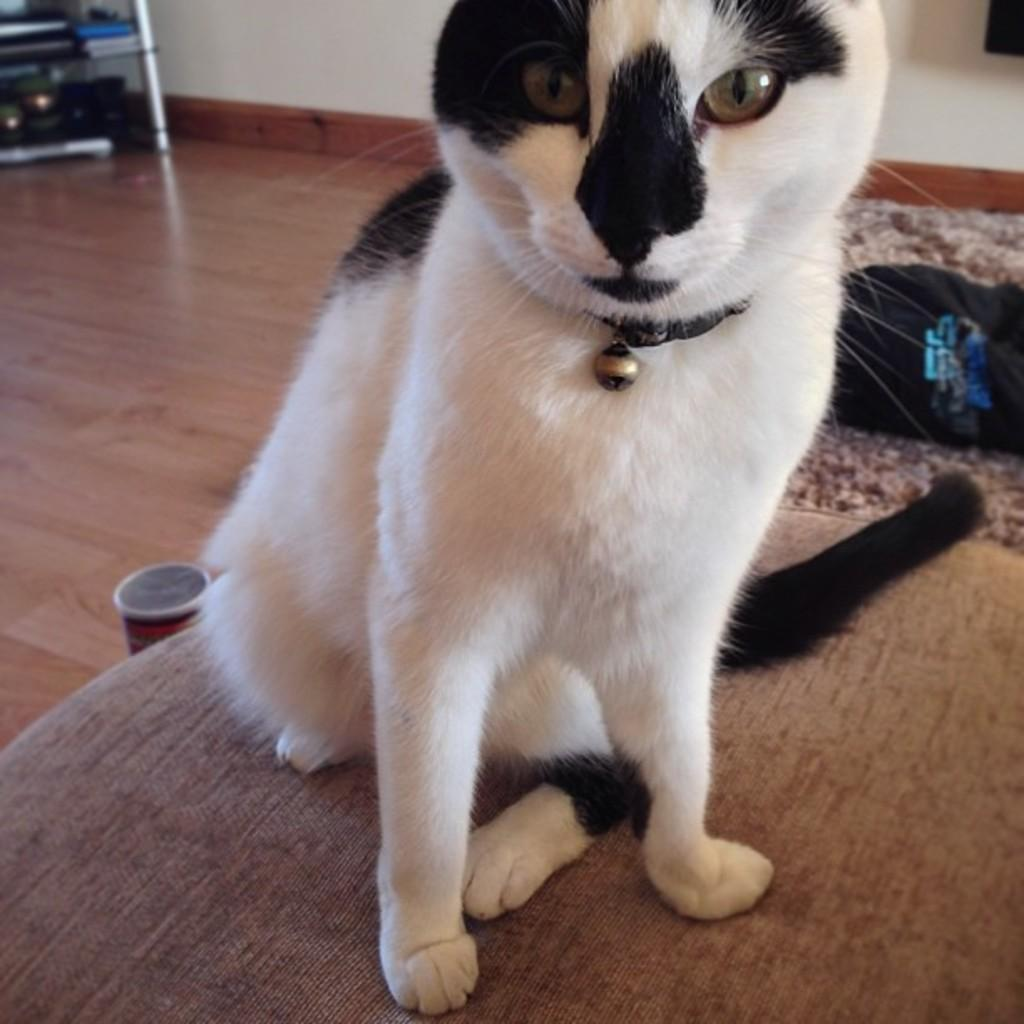What type of animal is on a cushion in the image? There is a cat on a cushion in the image. What can be seen in the background of the image? There is a rack with objects and a wall visible in the background of the image. What other items are present in the background of the image? There are items present in the background of the image. What type of tomatoes can be seen growing on the wall in the image? There are no tomatoes present in the image, and the wall does not have any plants growing on it. 